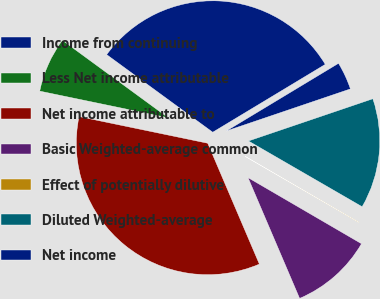<chart> <loc_0><loc_0><loc_500><loc_500><pie_chart><fcel>Income from continuing<fcel>Less Net income attributable<fcel>Net income attributable to<fcel>Basic Weighted-average common<fcel>Effect of potentially dilutive<fcel>Diluted Weighted-average<fcel>Net income<nl><fcel>31.31%<fcel>6.8%<fcel>34.68%<fcel>10.18%<fcel>0.05%<fcel>13.55%<fcel>3.43%<nl></chart> 